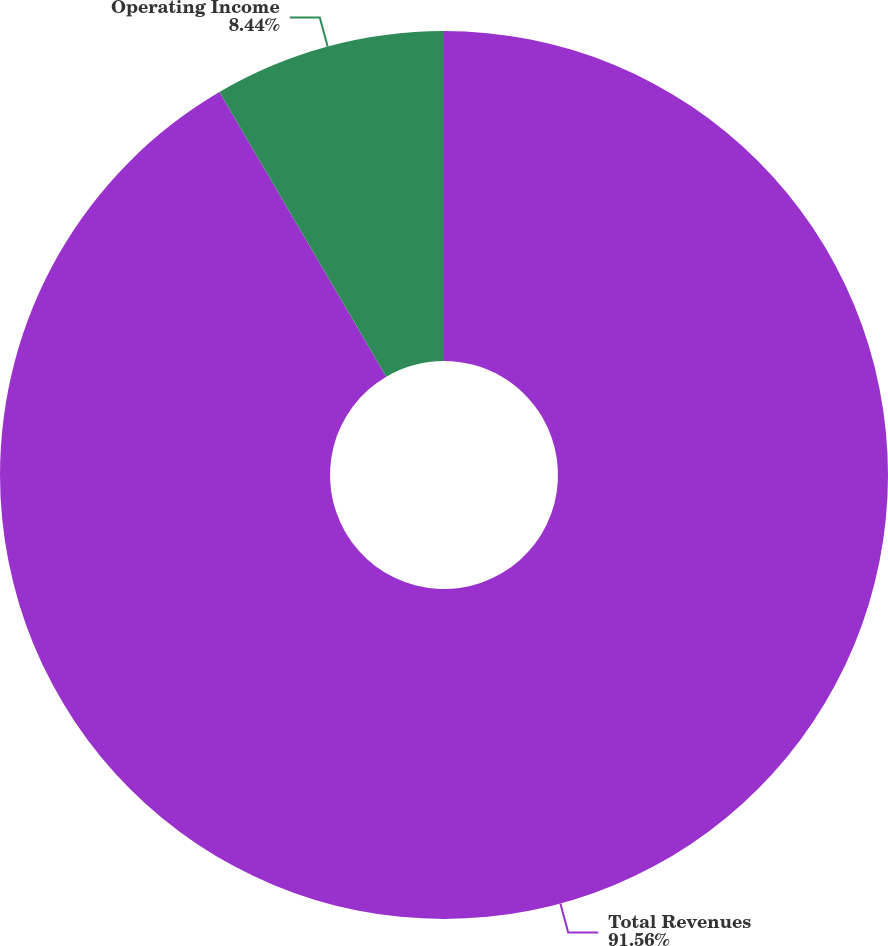<chart> <loc_0><loc_0><loc_500><loc_500><pie_chart><fcel>Total Revenues<fcel>Operating Income<nl><fcel>91.56%<fcel>8.44%<nl></chart> 